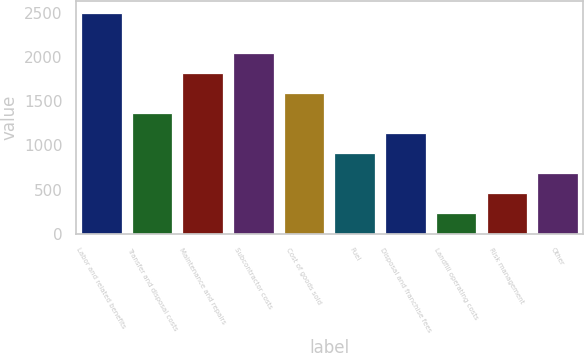Convert chart to OTSL. <chart><loc_0><loc_0><loc_500><loc_500><bar_chart><fcel>Labor and related benefits<fcel>Transfer and disposal costs<fcel>Maintenance and repairs<fcel>Subcontractor costs<fcel>Cost of goods sold<fcel>Fuel<fcel>Disposal and franchise fees<fcel>Landfill operating costs<fcel>Risk management<fcel>Other<nl><fcel>2506<fcel>1369<fcel>1823.8<fcel>2051.2<fcel>1596.4<fcel>914.2<fcel>1141.6<fcel>232<fcel>459.4<fcel>686.8<nl></chart> 